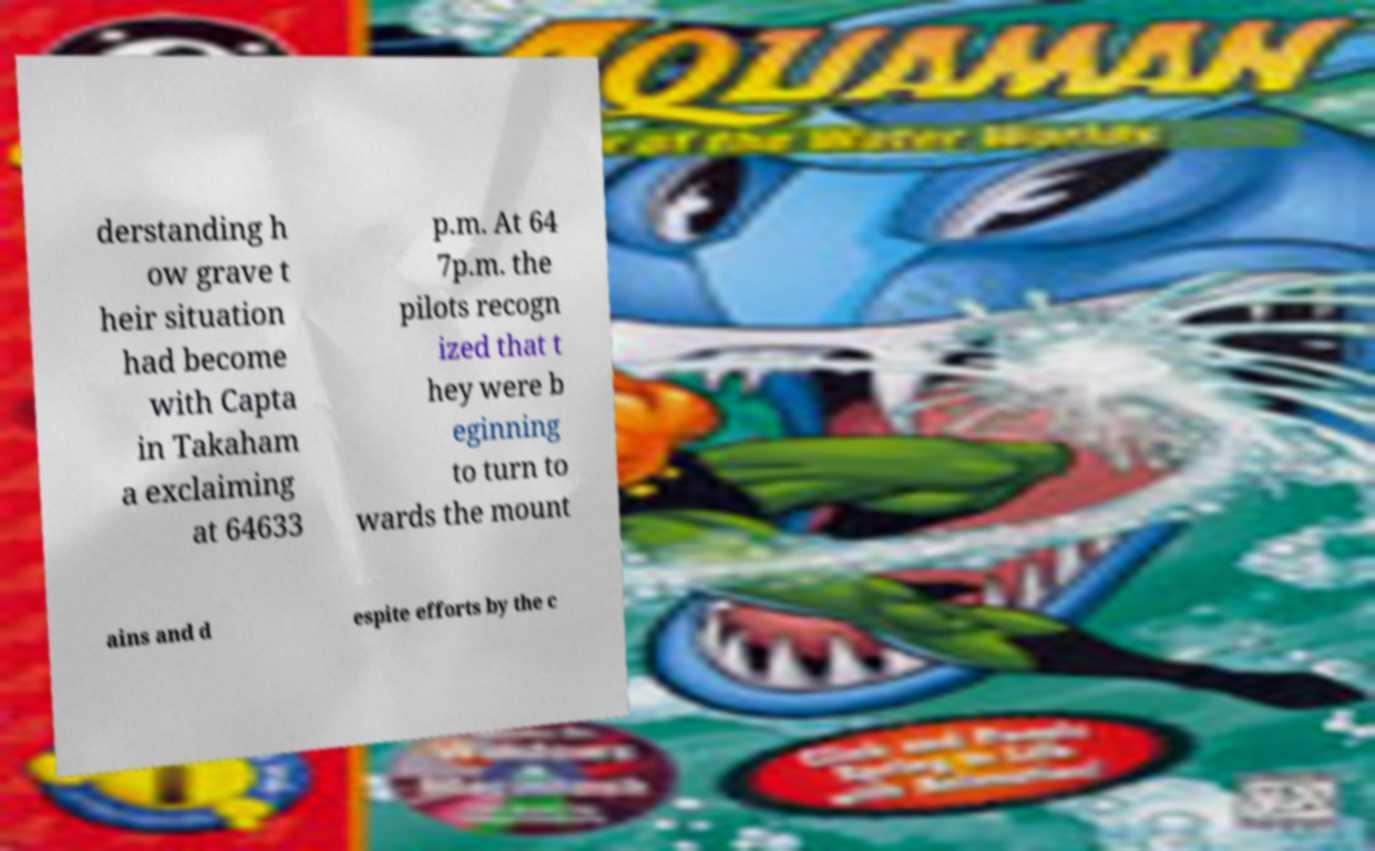Could you extract and type out the text from this image? derstanding h ow grave t heir situation had become with Capta in Takaham a exclaiming at 64633 p.m. At 64 7p.m. the pilots recogn ized that t hey were b eginning to turn to wards the mount ains and d espite efforts by the c 